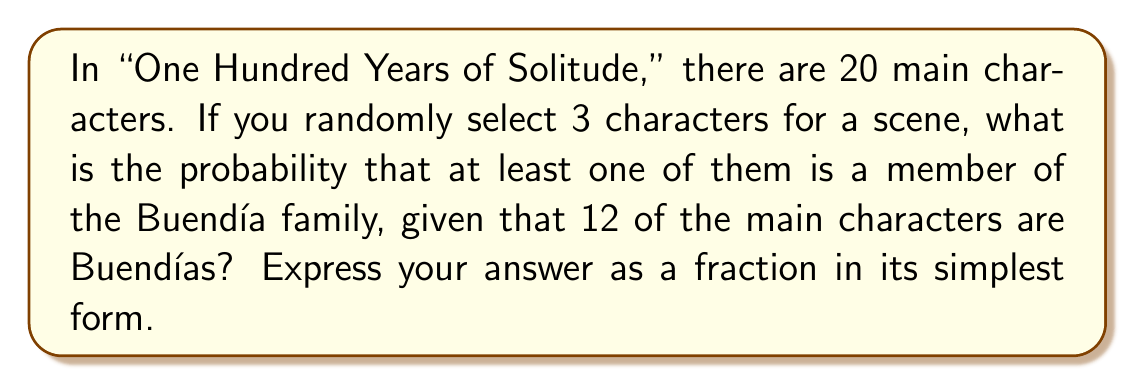Give your solution to this math problem. Let's approach this step-by-step using the concept of complementary probability:

1) First, let's calculate the total number of ways to select 3 characters out of 20:
   $$\binom{20}{3} = \frac{20!}{3!(20-3)!} = \frac{20!}{3!17!} = 1140$$

2) Now, let's calculate the number of ways to select 3 non-Buendía characters:
   There are 8 non-Buendía characters (20 - 12 = 8)
   $$\binom{8}{3} = \frac{8!}{3!(8-3)!} = \frac{8!}{3!5!} = 56$$

3) The probability of selecting 3 non-Buendía characters is:
   $$P(\text{no Buendía}) = \frac{56}{1140} = \frac{7}{142}$$

4) The probability of selecting at least one Buendía is the complement of this probability:
   $$P(\text{at least one Buendía}) = 1 - P(\text{no Buendía}) = 1 - \frac{7}{142} = \frac{135}{142}$$

5) This fraction is already in its simplest form as 135 and 142 have no common factors other than 1.
Answer: $\frac{135}{142}$ 